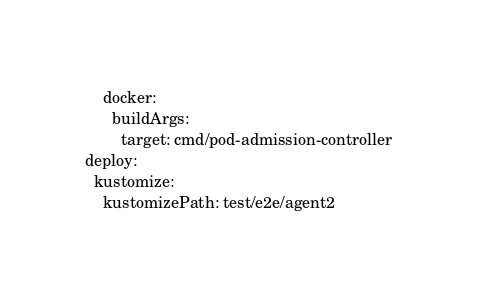<code> <loc_0><loc_0><loc_500><loc_500><_YAML_>    docker:
      buildArgs:
        target: cmd/pod-admission-controller
deploy:
  kustomize:
    kustomizePath: test/e2e/agent2
</code> 